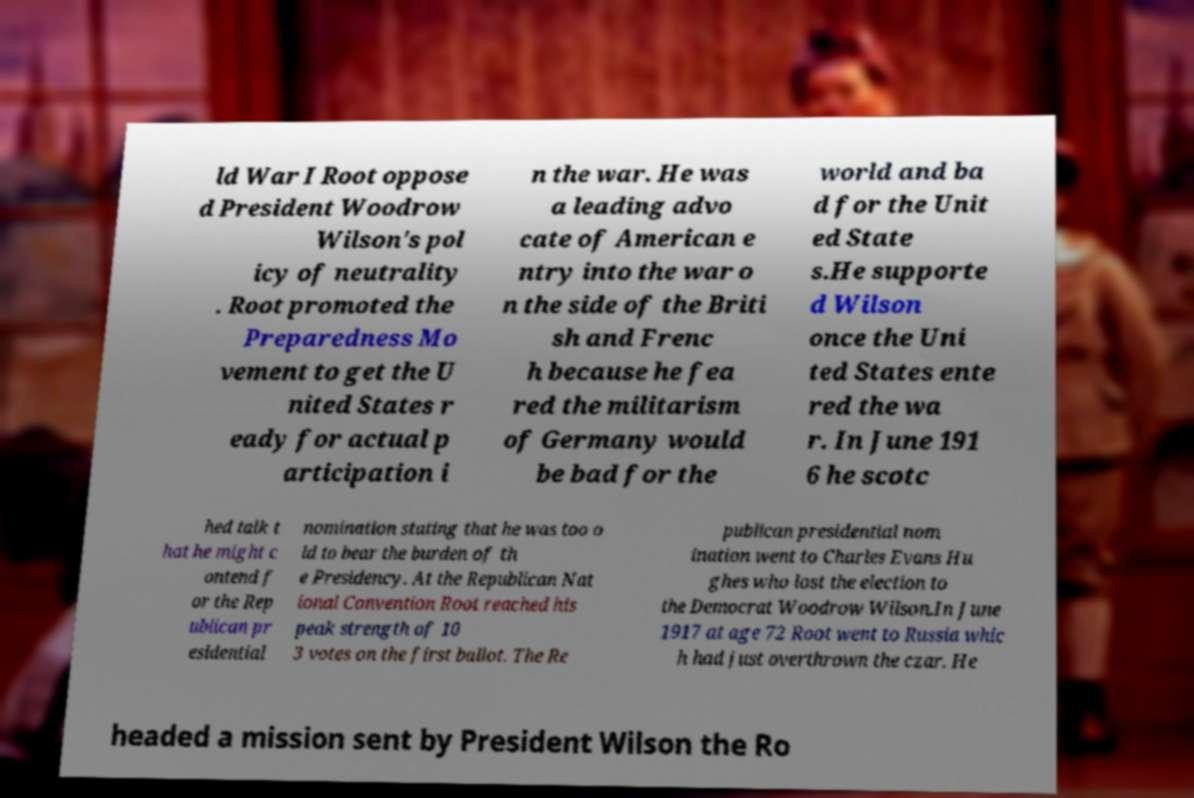Could you assist in decoding the text presented in this image and type it out clearly? ld War I Root oppose d President Woodrow Wilson's pol icy of neutrality . Root promoted the Preparedness Mo vement to get the U nited States r eady for actual p articipation i n the war. He was a leading advo cate of American e ntry into the war o n the side of the Briti sh and Frenc h because he fea red the militarism of Germany would be bad for the world and ba d for the Unit ed State s.He supporte d Wilson once the Uni ted States ente red the wa r. In June 191 6 he scotc hed talk t hat he might c ontend f or the Rep ublican pr esidential nomination stating that he was too o ld to bear the burden of th e Presidency. At the Republican Nat ional Convention Root reached his peak strength of 10 3 votes on the first ballot. The Re publican presidential nom ination went to Charles Evans Hu ghes who lost the election to the Democrat Woodrow Wilson.In June 1917 at age 72 Root went to Russia whic h had just overthrown the czar. He headed a mission sent by President Wilson the Ro 